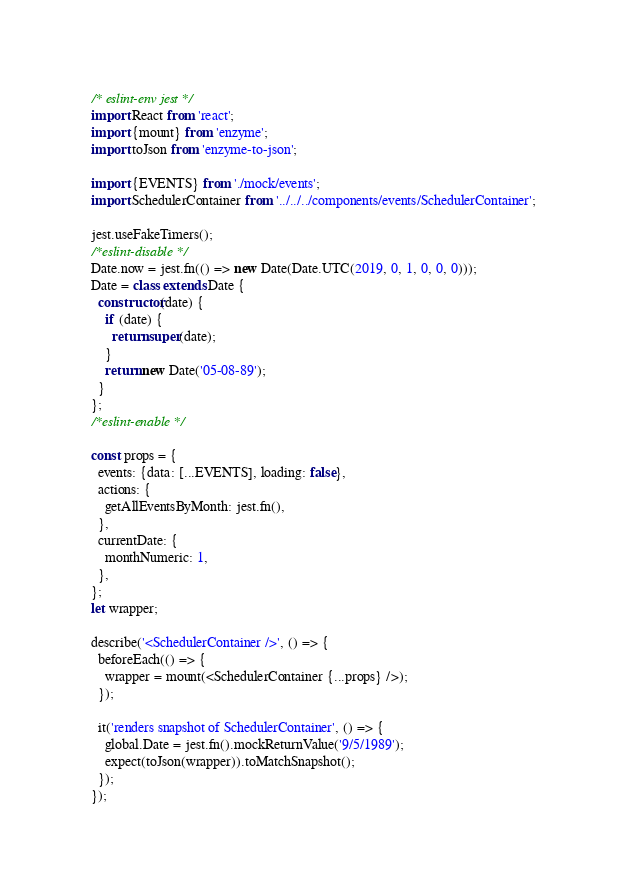<code> <loc_0><loc_0><loc_500><loc_500><_JavaScript_>/* eslint-env jest */
import React from 'react';
import {mount} from 'enzyme';
import toJson from 'enzyme-to-json';

import {EVENTS} from './mock/events';
import SchedulerContainer from '../../../components/events/SchedulerContainer';

jest.useFakeTimers();
/*eslint-disable */
Date.now = jest.fn(() => new Date(Date.UTC(2019, 0, 1, 0, 0, 0)));
Date = class extends Date {
  constructor(date) {
    if (date) {
      return super(date);
    }
    return new Date('05-08-89');
  }
};
/*eslint-enable */

const props = {
  events: {data: [...EVENTS], loading: false},
  actions: {
    getAllEventsByMonth: jest.fn(),
  },
  currentDate: {
    monthNumeric: 1,
  },
};
let wrapper;

describe('<SchedulerContainer />', () => {
  beforeEach(() => {
    wrapper = mount(<SchedulerContainer {...props} />);
  });

  it('renders snapshot of SchedulerContainer', () => {
    global.Date = jest.fn().mockReturnValue('9/5/1989');
    expect(toJson(wrapper)).toMatchSnapshot();
  });
});
</code> 